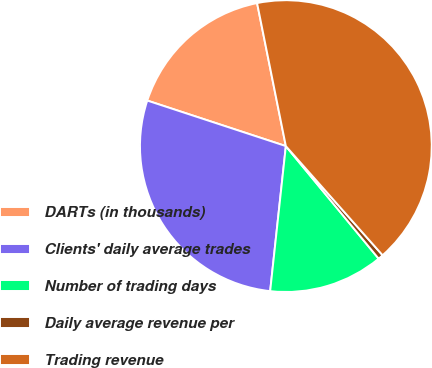Convert chart to OTSL. <chart><loc_0><loc_0><loc_500><loc_500><pie_chart><fcel>DARTs (in thousands)<fcel>Clients' daily average trades<fcel>Number of trading days<fcel>Daily average revenue per<fcel>Trading revenue<nl><fcel>16.79%<fcel>28.34%<fcel>12.69%<fcel>0.57%<fcel>41.62%<nl></chart> 